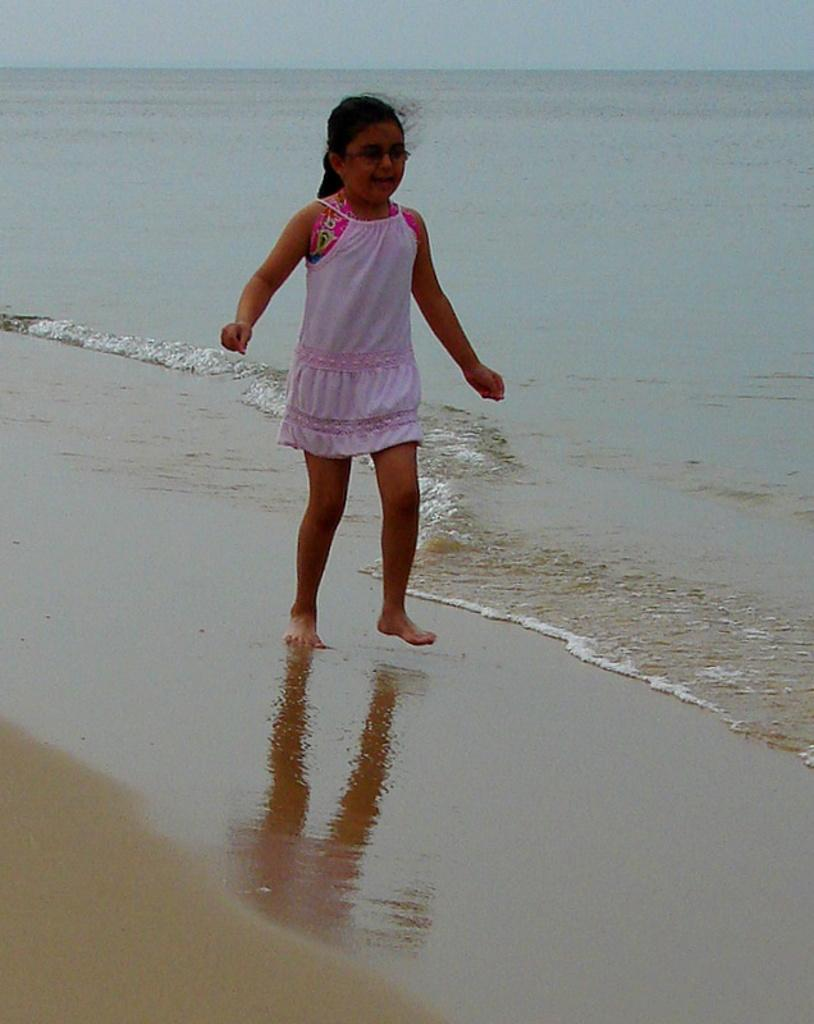Who is the main subject in the image? There is a girl in the center of the image. What is the girl doing in the image? The girl is walking. What is the girl's facial expression in the image? The girl is smiling. What accessory is the girl wearing in the image? The girl is wearing glasses. What can be seen in the background of the image? There is sky and water visible in the background of the image. What type of table is the girl sitting on in the image? There is no table present in the image; the girl is walking. What is the girl's reaction to the expansion of the universe in the image? There is no mention of the universe or any expansion in the image; the girl is simply walking and smiling. 